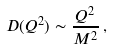Convert formula to latex. <formula><loc_0><loc_0><loc_500><loc_500>D ( Q ^ { 2 } ) \sim \frac { Q ^ { 2 } } { M ^ { 2 } } \, ,</formula> 